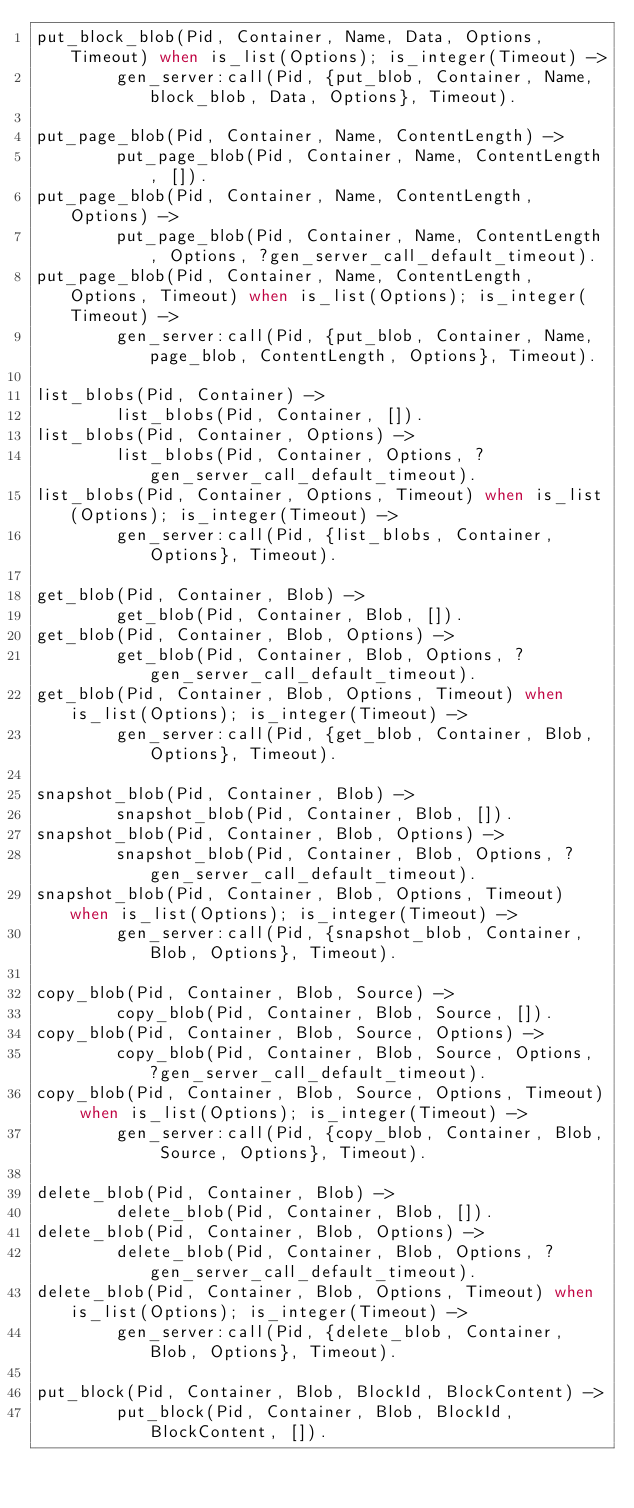Convert code to text. <code><loc_0><loc_0><loc_500><loc_500><_Erlang_>put_block_blob(Pid, Container, Name, Data, Options, Timeout) when is_list(Options); is_integer(Timeout) ->
        gen_server:call(Pid, {put_blob, Container, Name, block_blob, Data, Options}, Timeout).

put_page_blob(Pid, Container, Name, ContentLength) ->
        put_page_blob(Pid, Container, Name, ContentLength, []).
put_page_blob(Pid, Container, Name, ContentLength, Options) ->
        put_page_blob(Pid, Container, Name, ContentLength, Options, ?gen_server_call_default_timeout).
put_page_blob(Pid, Container, Name, ContentLength, Options, Timeout) when is_list(Options); is_integer(Timeout) ->
        gen_server:call(Pid, {put_blob, Container, Name, page_blob, ContentLength, Options}, Timeout).

list_blobs(Pid, Container) ->
        list_blobs(Pid, Container, []).
list_blobs(Pid, Container, Options) ->
        list_blobs(Pid, Container, Options, ?gen_server_call_default_timeout).
list_blobs(Pid, Container, Options, Timeout) when is_list(Options); is_integer(Timeout) ->
        gen_server:call(Pid, {list_blobs, Container, Options}, Timeout).

get_blob(Pid, Container, Blob) ->
        get_blob(Pid, Container, Blob, []).
get_blob(Pid, Container, Blob, Options) ->
        get_blob(Pid, Container, Blob, Options, ?gen_server_call_default_timeout).
get_blob(Pid, Container, Blob, Options, Timeout) when is_list(Options); is_integer(Timeout) ->
        gen_server:call(Pid, {get_blob, Container, Blob, Options}, Timeout).

snapshot_blob(Pid, Container, Blob) ->
        snapshot_blob(Pid, Container, Blob, []).
snapshot_blob(Pid, Container, Blob, Options) ->
        snapshot_blob(Pid, Container, Blob, Options, ?gen_server_call_default_timeout).
snapshot_blob(Pid, Container, Blob, Options, Timeout) when is_list(Options); is_integer(Timeout) ->
        gen_server:call(Pid, {snapshot_blob, Container, Blob, Options}, Timeout).

copy_blob(Pid, Container, Blob, Source) ->
        copy_blob(Pid, Container, Blob, Source, []).
copy_blob(Pid, Container, Blob, Source, Options) ->
        copy_blob(Pid, Container, Blob, Source, Options, ?gen_server_call_default_timeout).
copy_blob(Pid, Container, Blob, Source, Options, Timeout) when is_list(Options); is_integer(Timeout) ->
        gen_server:call(Pid, {copy_blob, Container, Blob, Source, Options}, Timeout).

delete_blob(Pid, Container, Blob) ->
        delete_blob(Pid, Container, Blob, []).
delete_blob(Pid, Container, Blob, Options) ->
        delete_blob(Pid, Container, Blob, Options, ?gen_server_call_default_timeout).
delete_blob(Pid, Container, Blob, Options, Timeout) when is_list(Options); is_integer(Timeout) ->
        gen_server:call(Pid, {delete_blob, Container, Blob, Options}, Timeout).

put_block(Pid, Container, Blob, BlockId, BlockContent) ->
        put_block(Pid, Container, Blob, BlockId, BlockContent, []).</code> 